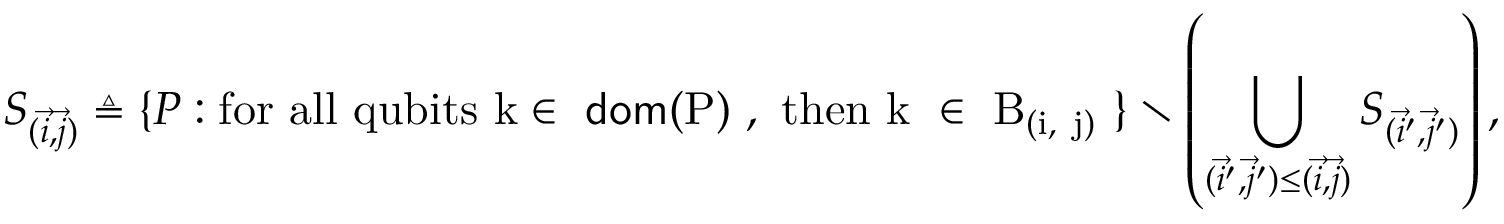<formula> <loc_0><loc_0><loc_500><loc_500>S _ { ( \vec { i } , \vec { j } ) } \triangle q \{ P \colon f o r a l l q u b i t s k \in d o m ( P ) , t h e n k \in B _ { ( \vec { i } , \vec { j } ) } \} \ \left ( \bigcup _ { ( \vec { i } ^ { \prime } , \vec { j } ^ { \prime } ) \leq ( \vec { i } , \vec { j } ) } S _ { ( \vec { i } ^ { \prime } , \vec { j } ^ { \prime } ) } \right ) ,</formula> 